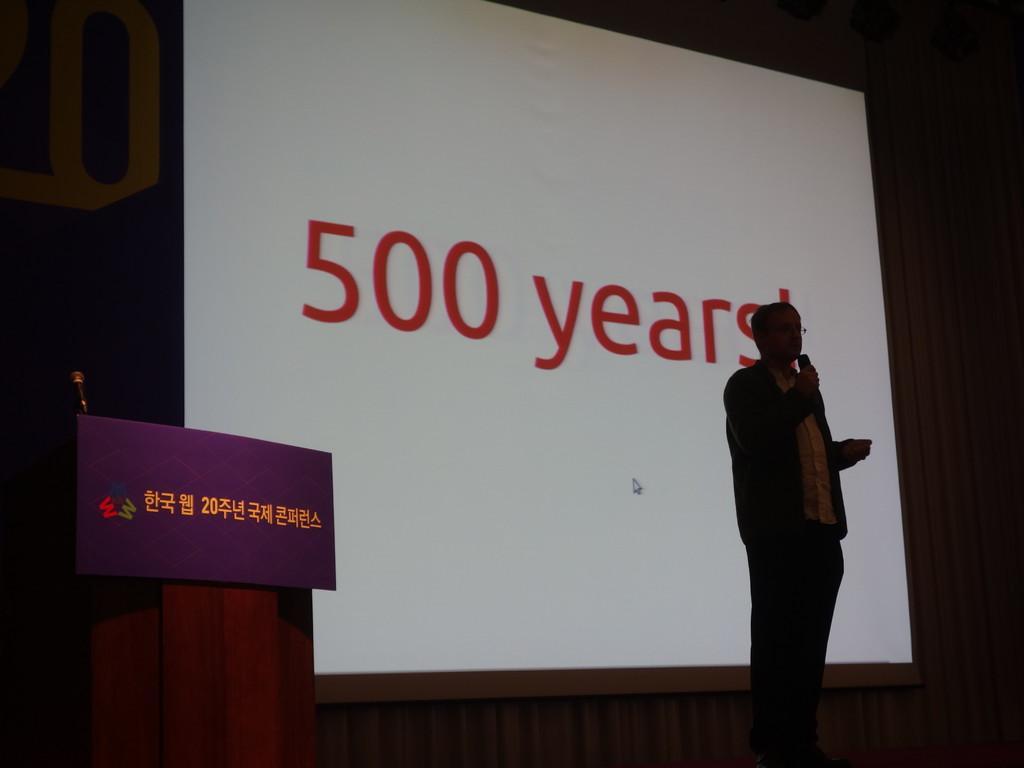Can you describe this image briefly? In this image we can see a man is standing and holding mic. Behind screen is there. Left side of the image podium is present. 